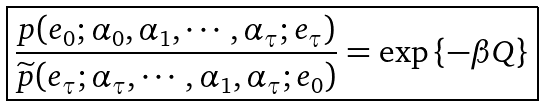<formula> <loc_0><loc_0><loc_500><loc_500>\boxed { \frac { p ( e _ { 0 } ; \alpha _ { 0 } , \alpha _ { 1 } , \cdots , \alpha _ { \tau } ; e _ { \tau } ) } { \widetilde { p } ( e _ { \tau } ; \alpha _ { \tau } , \cdots , \alpha _ { 1 } , \alpha _ { \tau } ; e _ { 0 } ) } = \exp \left \{ - \beta Q \right \} }</formula> 